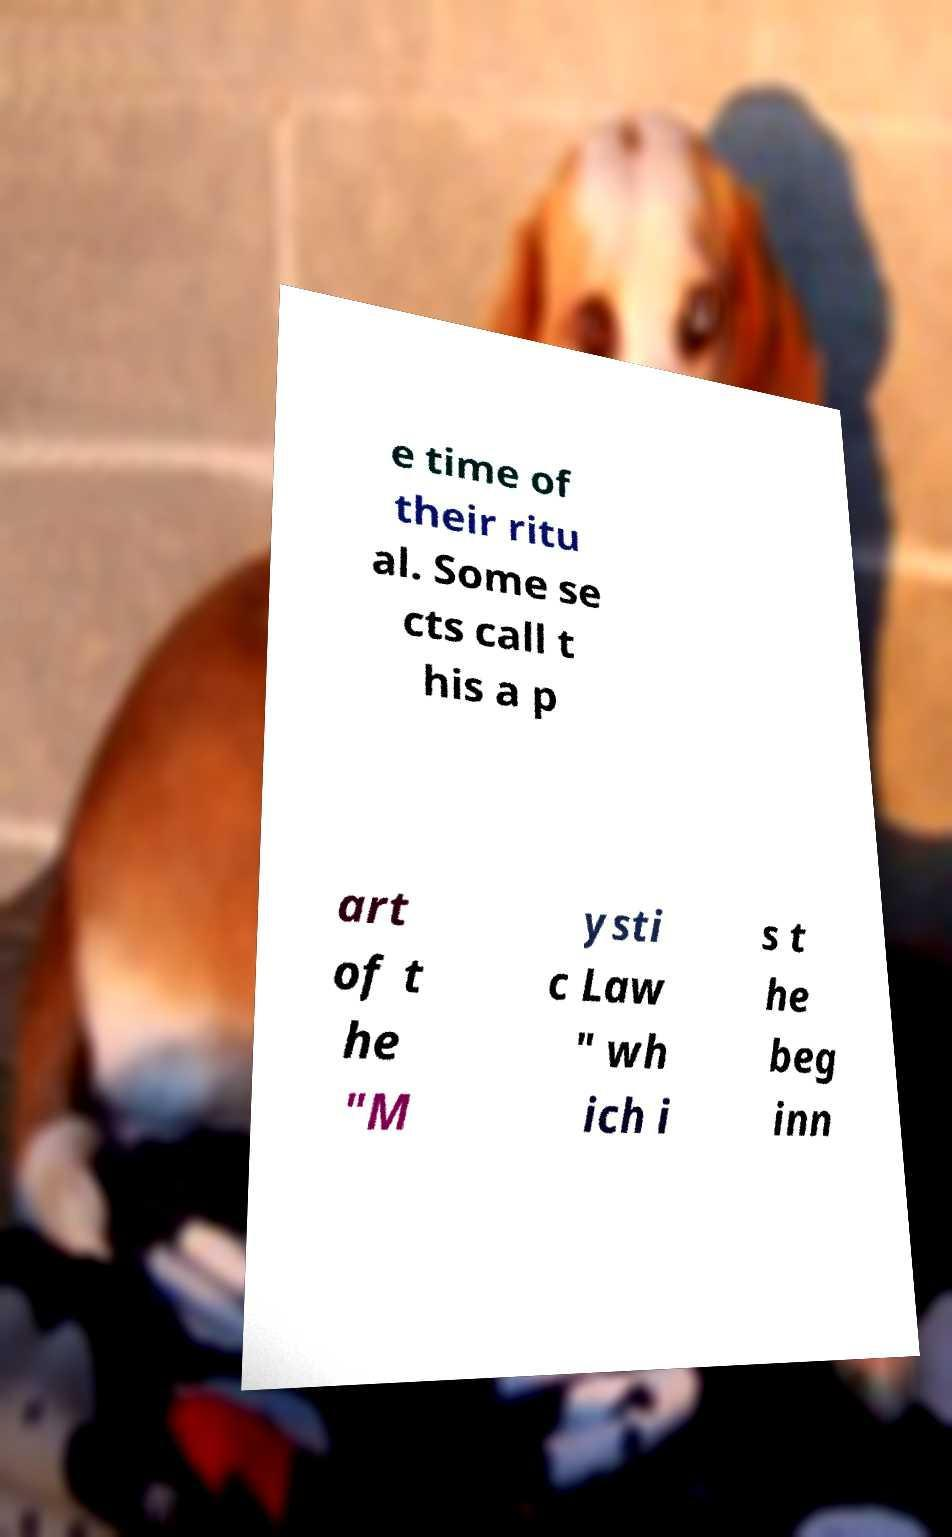Please read and relay the text visible in this image. What does it say? e time of their ritu al. Some se cts call t his a p art of t he "M ysti c Law " wh ich i s t he beg inn 